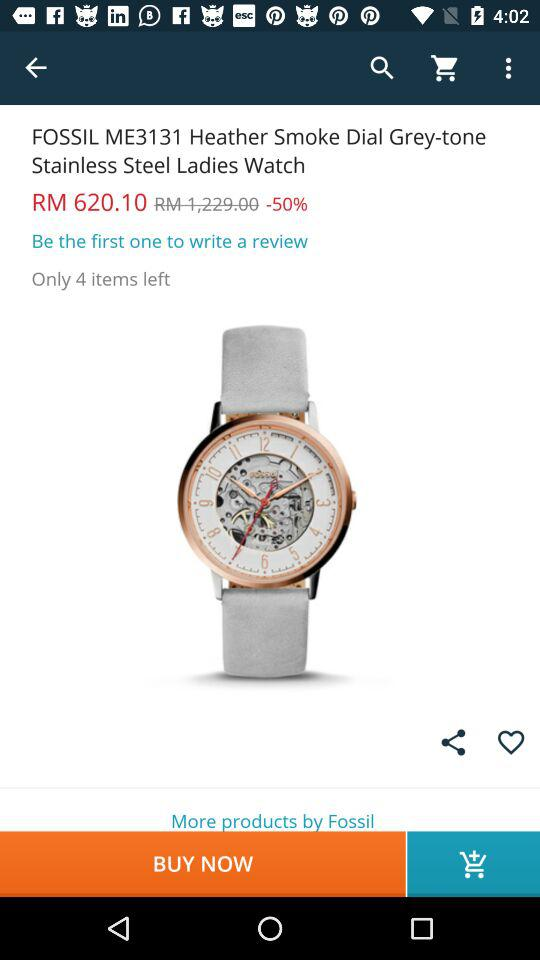Does this item have any review?
When the provided information is insufficient, respond with <no answer>. <no answer> 